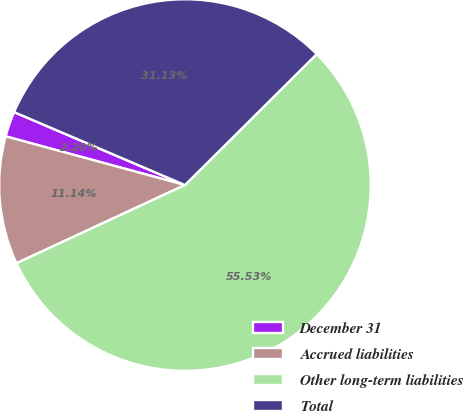Convert chart to OTSL. <chart><loc_0><loc_0><loc_500><loc_500><pie_chart><fcel>December 31<fcel>Accrued liabilities<fcel>Other long-term liabilities<fcel>Total<nl><fcel>2.2%<fcel>11.14%<fcel>55.53%<fcel>31.13%<nl></chart> 